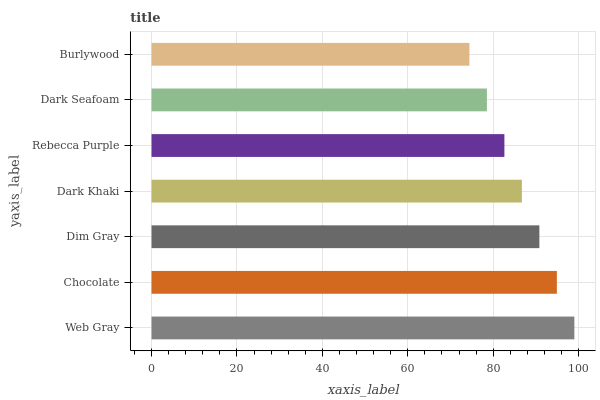Is Burlywood the minimum?
Answer yes or no. Yes. Is Web Gray the maximum?
Answer yes or no. Yes. Is Chocolate the minimum?
Answer yes or no. No. Is Chocolate the maximum?
Answer yes or no. No. Is Web Gray greater than Chocolate?
Answer yes or no. Yes. Is Chocolate less than Web Gray?
Answer yes or no. Yes. Is Chocolate greater than Web Gray?
Answer yes or no. No. Is Web Gray less than Chocolate?
Answer yes or no. No. Is Dark Khaki the high median?
Answer yes or no. Yes. Is Dark Khaki the low median?
Answer yes or no. Yes. Is Chocolate the high median?
Answer yes or no. No. Is Dark Seafoam the low median?
Answer yes or no. No. 